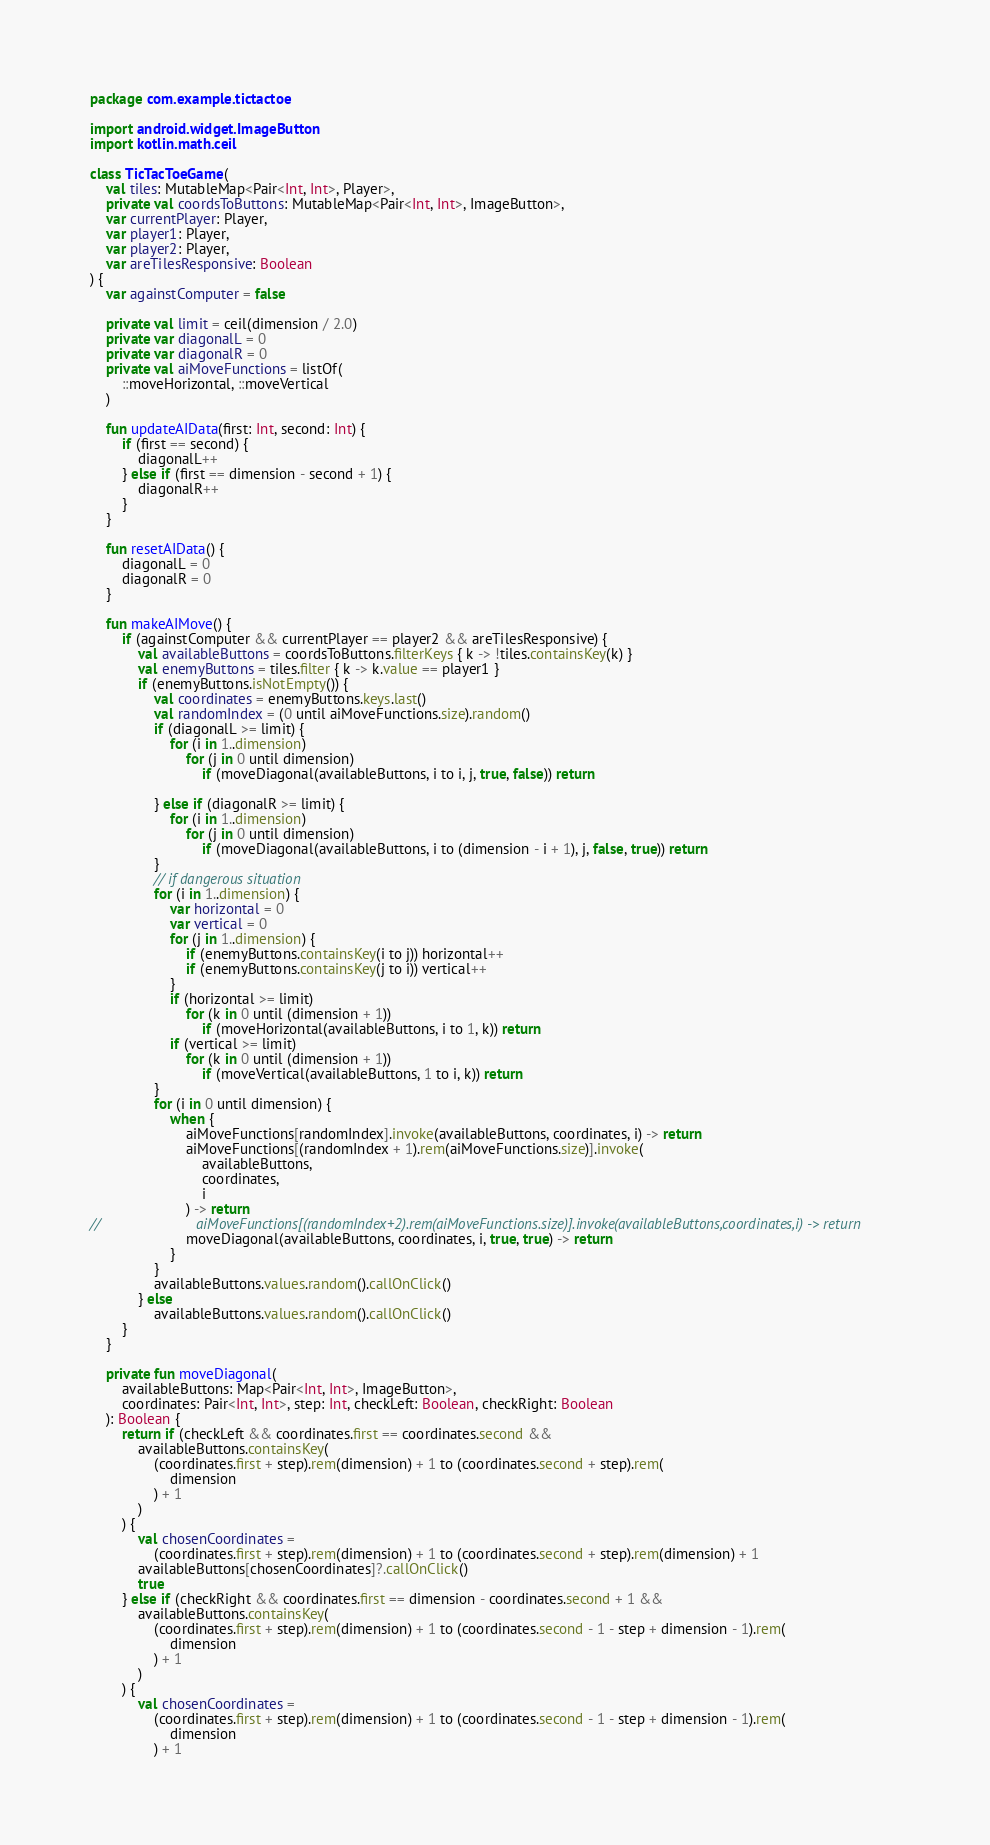Convert code to text. <code><loc_0><loc_0><loc_500><loc_500><_Kotlin_>package com.example.tictactoe

import android.widget.ImageButton
import kotlin.math.ceil

class TicTacToeGame(
    val tiles: MutableMap<Pair<Int, Int>, Player>,
    private val coordsToButtons: MutableMap<Pair<Int, Int>, ImageButton>,
    var currentPlayer: Player,
    var player1: Player,
    var player2: Player,
    var areTilesResponsive: Boolean
) {
    var againstComputer = false

    private val limit = ceil(dimension / 2.0)
    private var diagonalL = 0
    private var diagonalR = 0
    private val aiMoveFunctions = listOf(
        ::moveHorizontal, ::moveVertical
    )

    fun updateAIData(first: Int, second: Int) {
        if (first == second) {
            diagonalL++
        } else if (first == dimension - second + 1) {
            diagonalR++
        }
    }

    fun resetAIData() {
        diagonalL = 0
        diagonalR = 0
    }

    fun makeAIMove() {
        if (againstComputer && currentPlayer == player2 && areTilesResponsive) {
            val availableButtons = coordsToButtons.filterKeys { k -> !tiles.containsKey(k) }
            val enemyButtons = tiles.filter { k -> k.value == player1 }
            if (enemyButtons.isNotEmpty()) {
                val coordinates = enemyButtons.keys.last()
                val randomIndex = (0 until aiMoveFunctions.size).random()
                if (diagonalL >= limit) {
                    for (i in 1..dimension)
                        for (j in 0 until dimension)
                            if (moveDiagonal(availableButtons, i to i, j, true, false)) return

                } else if (diagonalR >= limit) {
                    for (i in 1..dimension)
                        for (j in 0 until dimension)
                            if (moveDiagonal(availableButtons, i to (dimension - i + 1), j, false, true)) return
                }
                // if dangerous situation
                for (i in 1..dimension) {
                    var horizontal = 0
                    var vertical = 0
                    for (j in 1..dimension) {
                        if (enemyButtons.containsKey(i to j)) horizontal++
                        if (enemyButtons.containsKey(j to i)) vertical++
                    }
                    if (horizontal >= limit)
                        for (k in 0 until (dimension + 1))
                            if (moveHorizontal(availableButtons, i to 1, k)) return
                    if (vertical >= limit)
                        for (k in 0 until (dimension + 1))
                            if (moveVertical(availableButtons, 1 to i, k)) return
                }
                for (i in 0 until dimension) {
                    when {
                        aiMoveFunctions[randomIndex].invoke(availableButtons, coordinates, i) -> return
                        aiMoveFunctions[(randomIndex + 1).rem(aiMoveFunctions.size)].invoke(
                            availableButtons,
                            coordinates,
                            i
                        ) -> return
//                        aiMoveFunctions[(randomIndex+2).rem(aiMoveFunctions.size)].invoke(availableButtons,coordinates,i) -> return
                        moveDiagonal(availableButtons, coordinates, i, true, true) -> return
                    }
                }
                availableButtons.values.random().callOnClick()
            } else
                availableButtons.values.random().callOnClick()
        }
    }

    private fun moveDiagonal(
        availableButtons: Map<Pair<Int, Int>, ImageButton>,
        coordinates: Pair<Int, Int>, step: Int, checkLeft: Boolean, checkRight: Boolean
    ): Boolean {
        return if (checkLeft && coordinates.first == coordinates.second &&
            availableButtons.containsKey(
                (coordinates.first + step).rem(dimension) + 1 to (coordinates.second + step).rem(
                    dimension
                ) + 1
            )
        ) {
            val chosenCoordinates =
                (coordinates.first + step).rem(dimension) + 1 to (coordinates.second + step).rem(dimension) + 1
            availableButtons[chosenCoordinates]?.callOnClick()
            true
        } else if (checkRight && coordinates.first == dimension - coordinates.second + 1 &&
            availableButtons.containsKey(
                (coordinates.first + step).rem(dimension) + 1 to (coordinates.second - 1 - step + dimension - 1).rem(
                    dimension
                ) + 1
            )
        ) {
            val chosenCoordinates =
                (coordinates.first + step).rem(dimension) + 1 to (coordinates.second - 1 - step + dimension - 1).rem(
                    dimension
                ) + 1</code> 